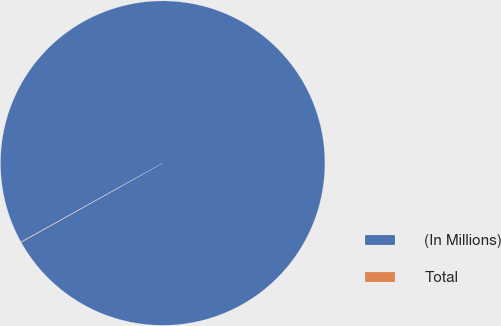<chart> <loc_0><loc_0><loc_500><loc_500><pie_chart><fcel>(In Millions)<fcel>Total<nl><fcel>99.96%<fcel>0.04%<nl></chart> 